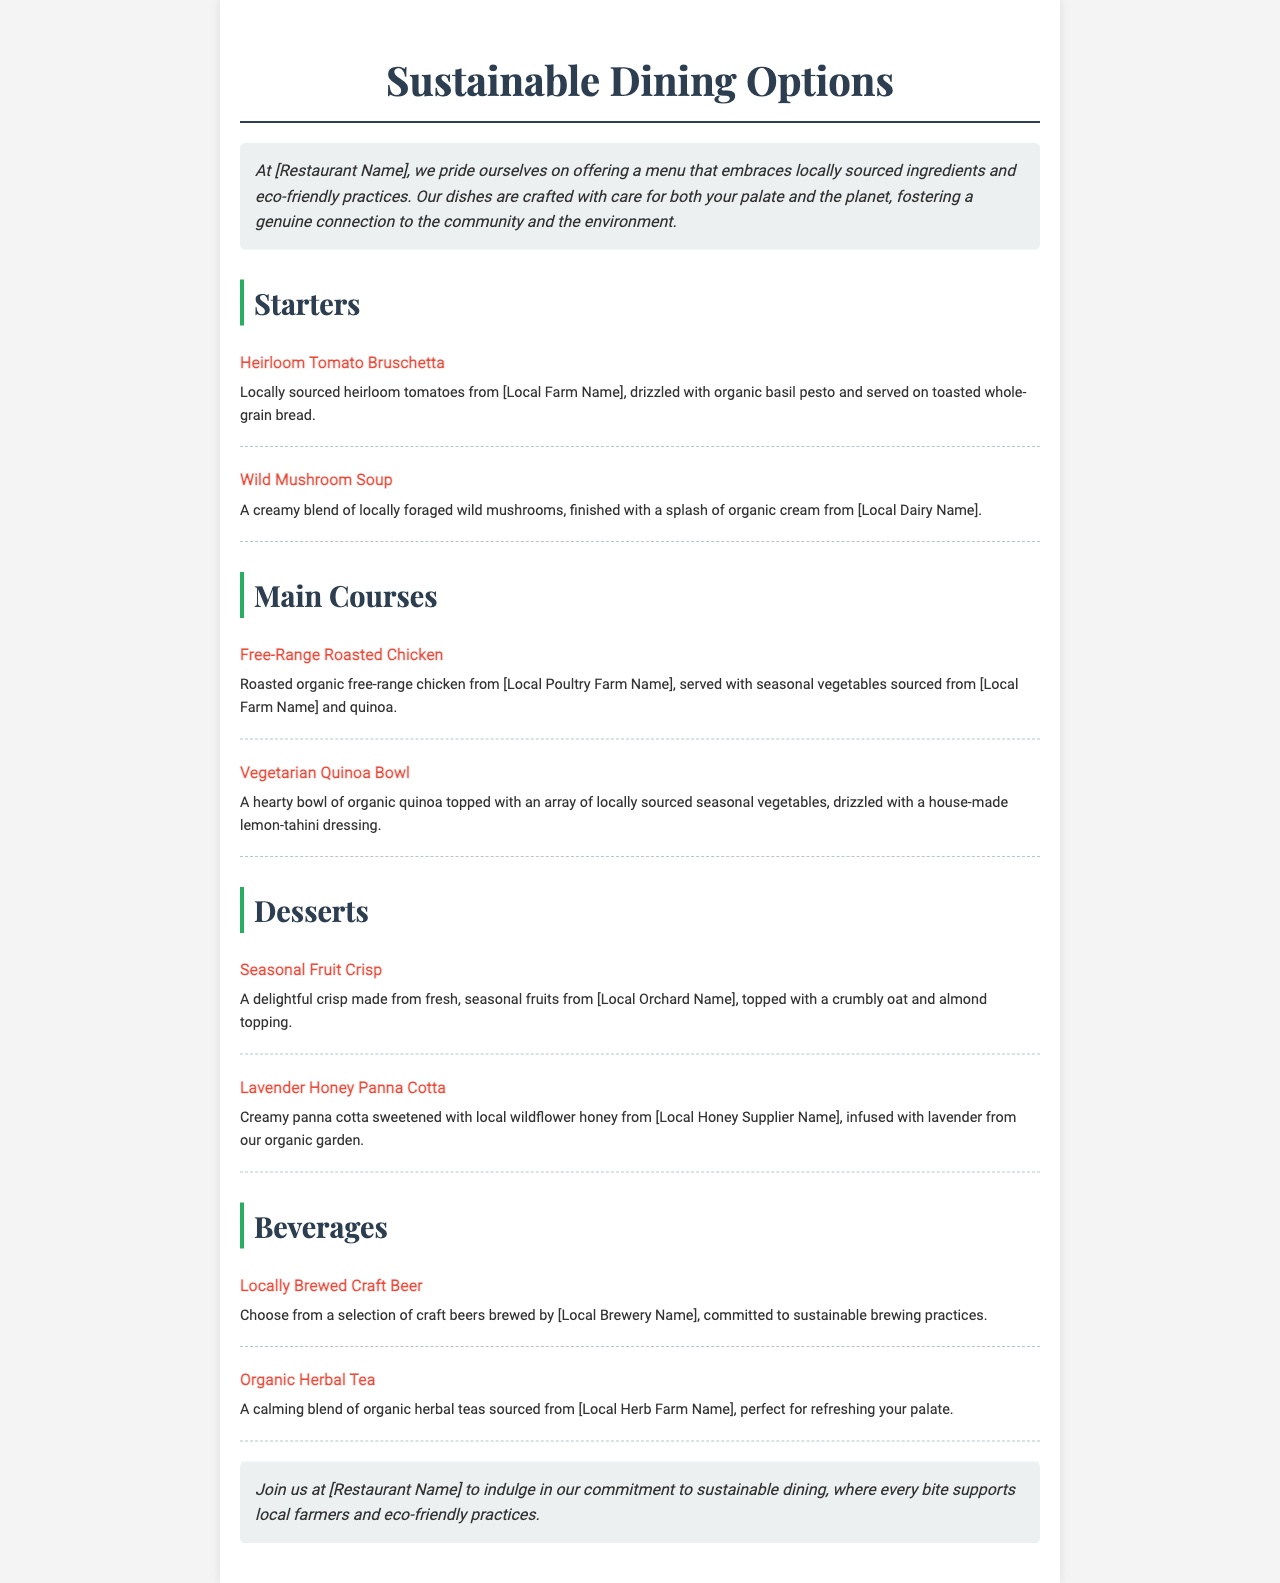What are the ingredients in the Heirloom Tomato Bruschetta? The Heirloom Tomato Bruschetta is made from locally sourced heirloom tomatoes, organic basil pesto, and toasted whole-grain bread.
Answer: heirloom tomatoes, organic basil pesto, toasted whole-grain bread Where does the wild mushrooms in the Wild Mushroom Soup come from? The wild mushrooms used in the Wild Mushroom Soup are locally foraged.
Answer: locally foraged What type of chicken is used in the Free-Range Roasted Chicken dish? The chicken used in the Free-Range Roasted Chicken dish is organic free-range chicken from a local poultry farm.
Answer: organic free-range chicken What is the main ingredient of the Vegetarian Quinoa Bowl? The main ingredient of the Vegetarian Quinoa Bowl is organic quinoa.
Answer: organic quinoa Which local supplier provides honey for the Lavender Honey Panna Cotta? The Lavender Honey Panna Cotta uses honey from a local wildflower honey supplier.
Answer: local wildflower honey supplier How is the craft beer selection characterized? The craft beer selection is characterized by being locally brewed and committed to sustainable brewing practices.
Answer: locally brewed, committed to sustainable practices What is the theme of the restaurant's approach? The theme of the restaurant's approach emphasizes sustainable dining options with locally sourced ingredients and eco-friendly practices.
Answer: sustainable dining options What type of tea is offered on the menu? The menu offers organic herbal tea.
Answer: organic herbal tea How many starters are listed in the menu? There are two starters listed in the menu.
Answer: two 